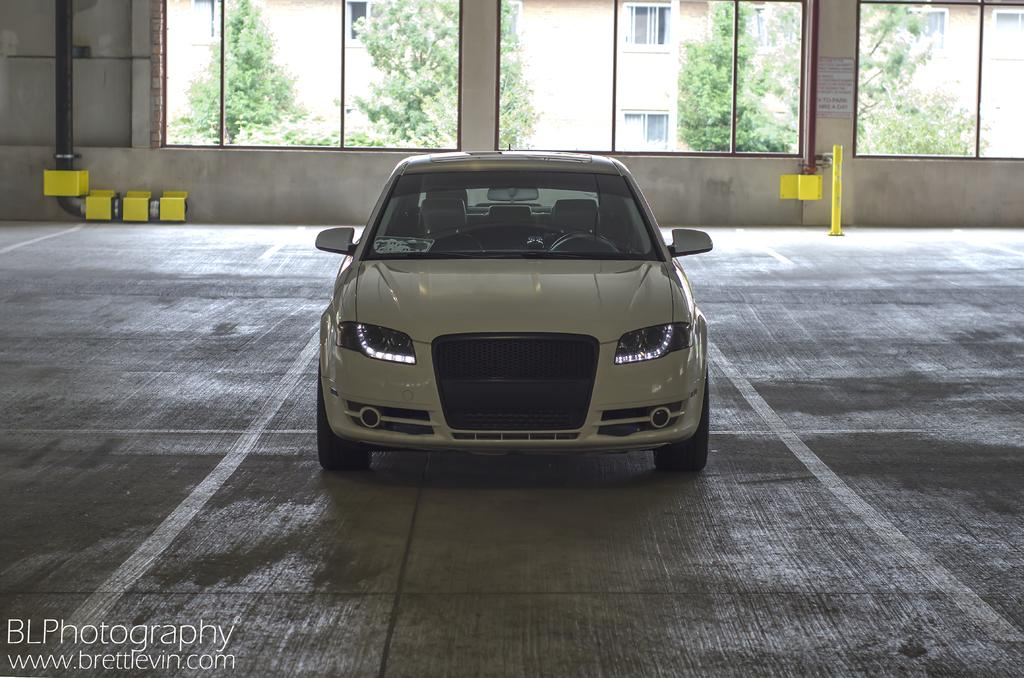What is the main subject of the image? The main subject of the image is a car. Can you describe the car's position in the image? The car is on a surface in the image. What can be seen in the background of the image? There are windows, trees, and buildings visible in the background of the image. What other objects are present in the image? There are poles and pipes in the image. What type of breakfast is being served in the image? There is no breakfast visible in the image; the image features a car on a surface with a background of windows, trees, and buildings, along with poles and pipes. 